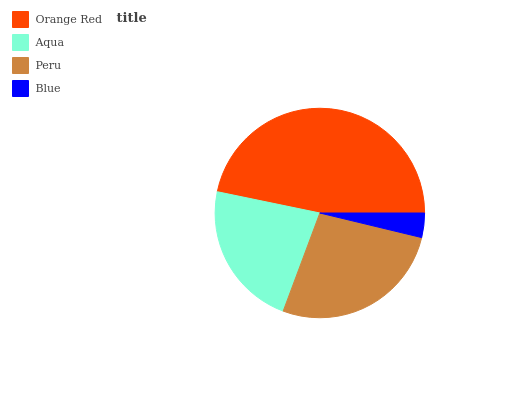Is Blue the minimum?
Answer yes or no. Yes. Is Orange Red the maximum?
Answer yes or no. Yes. Is Aqua the minimum?
Answer yes or no. No. Is Aqua the maximum?
Answer yes or no. No. Is Orange Red greater than Aqua?
Answer yes or no. Yes. Is Aqua less than Orange Red?
Answer yes or no. Yes. Is Aqua greater than Orange Red?
Answer yes or no. No. Is Orange Red less than Aqua?
Answer yes or no. No. Is Peru the high median?
Answer yes or no. Yes. Is Aqua the low median?
Answer yes or no. Yes. Is Aqua the high median?
Answer yes or no. No. Is Peru the low median?
Answer yes or no. No. 